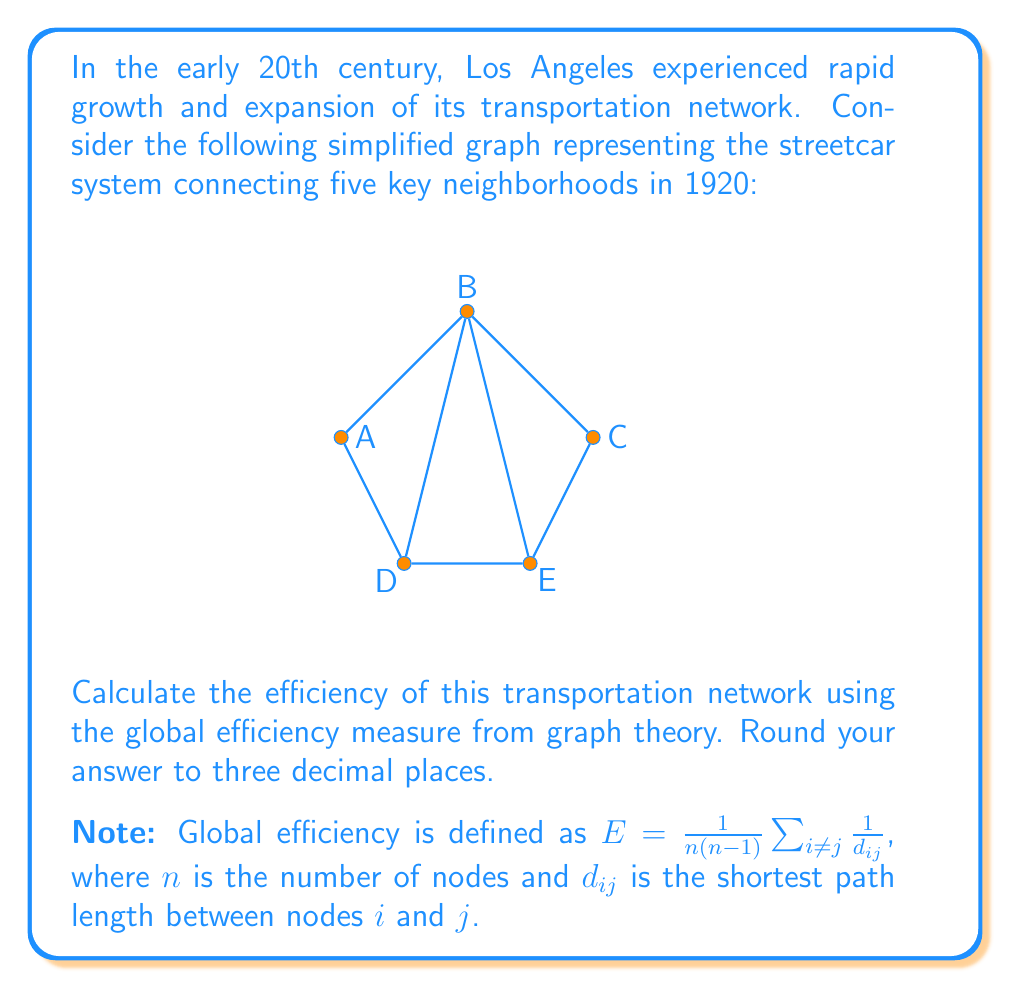Teach me how to tackle this problem. To solve this problem, we'll follow these steps:

1) First, we need to calculate the shortest path length ($d_{ij}$) between each pair of nodes.

2) Then, we'll sum the reciprocals of these distances.

3) Finally, we'll apply the global efficiency formula.

Step 1: Calculate shortest path lengths

A to B: 1
A to C: 2
A to D: 1
A to E: 2
B to C: 1
B to D: 1
B to E: 1
C to D: 2
C to E: 1
D to E: 1

Step 2: Sum the reciprocals of distances

$$\sum_{i \neq j} \frac{1}{d_{ij}} = 2(\frac{1}{1} + \frac{1}{2} + \frac{1}{1} + \frac{1}{2} + \frac{1}{1} + \frac{1}{1} + \frac{1}{1} + \frac{1}{2} + \frac{1}{1} + \frac{1}{1})$$
$$= 2(4 + 3 \cdot \frac{1}{2}) = 2(4 + 1.5) = 2(5.5) = 11$$

Step 3: Apply the global efficiency formula

$n = 5$ (number of nodes)

$$E = \frac{1}{n(n-1)} \sum_{i \neq j} \frac{1}{d_{ij}}$$
$$= \frac{1}{5(5-1)} \cdot 11$$
$$= \frac{11}{20} = 0.55$$

Therefore, the global efficiency of the network is 0.550 (rounded to three decimal places).
Answer: 0.550 